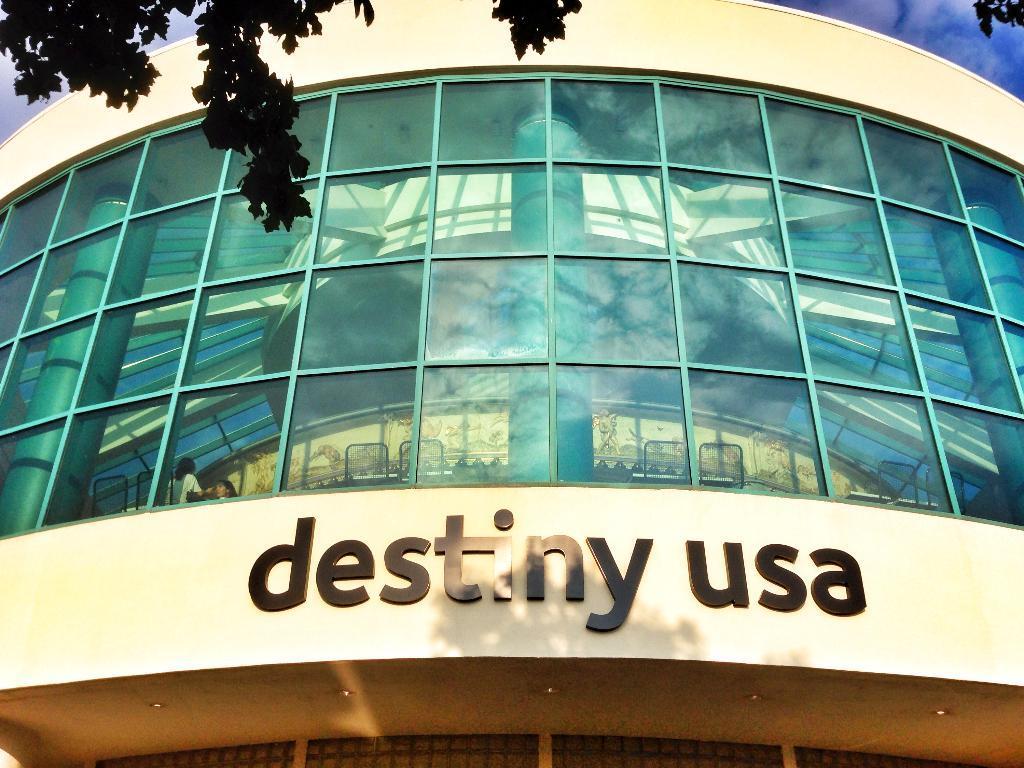Describe this image in one or two sentences. In the center of the image there is a building. At the top there are trees and sky. 